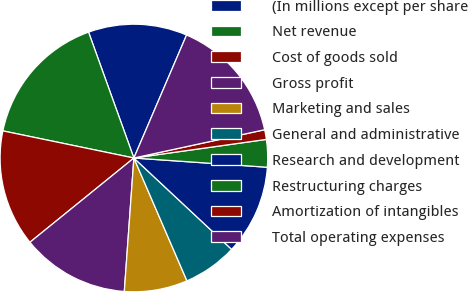Convert chart. <chart><loc_0><loc_0><loc_500><loc_500><pie_chart><fcel>(In millions except per share<fcel>Net revenue<fcel>Cost of goods sold<fcel>Gross profit<fcel>Marketing and sales<fcel>General and administrative<fcel>Research and development<fcel>Restructuring charges<fcel>Amortization of intangibles<fcel>Total operating expenses<nl><fcel>11.94%<fcel>16.25%<fcel>14.09%<fcel>13.02%<fcel>7.63%<fcel>6.55%<fcel>10.86%<fcel>3.32%<fcel>1.17%<fcel>15.17%<nl></chart> 